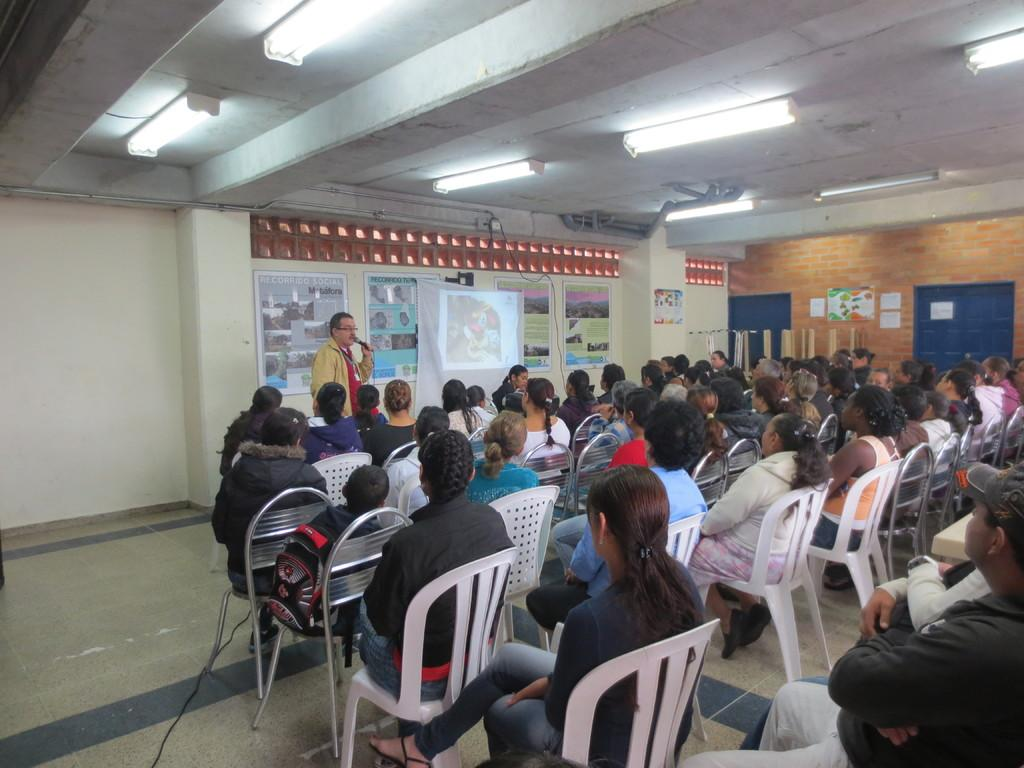What are the people in the image doing? The people in the image are sitting on chairs. What is the man in the image doing? The man is standing and holding a mic in his hand. What can be seen on the wall in the image? There are posters and a projector screen on the wall in the image. How many fingers does the man have on his left hand in the image? There is no information about the man's fingers in the image, so we cannot determine the number of fingers on his left hand. 